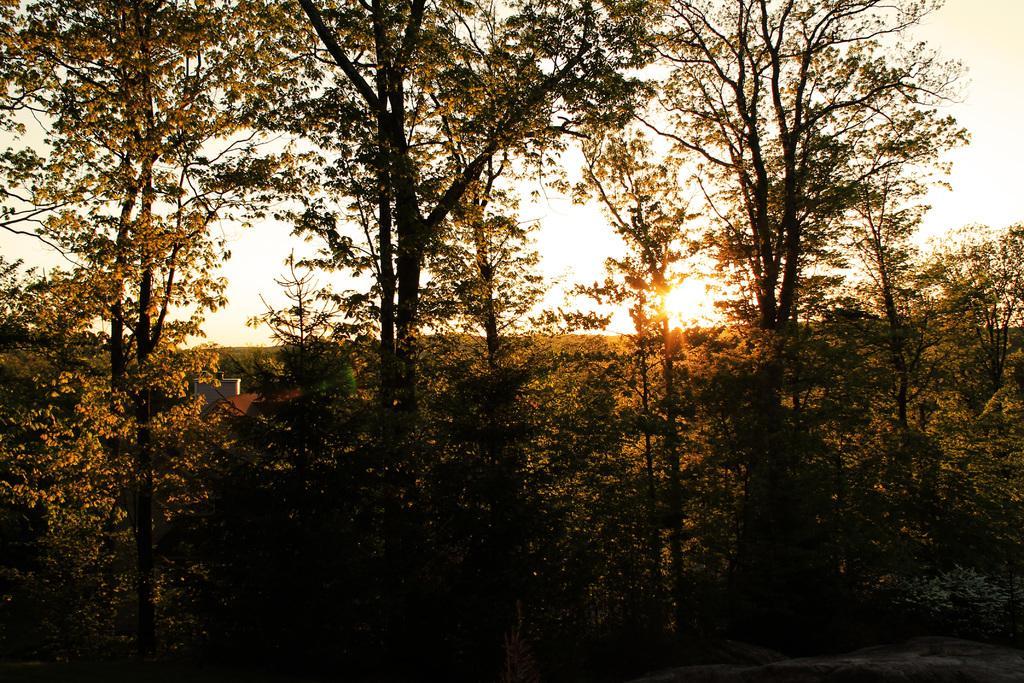Please provide a concise description of this image. In this image I can see many trees. At the top of the image I can see the sky along with the sunlight. 